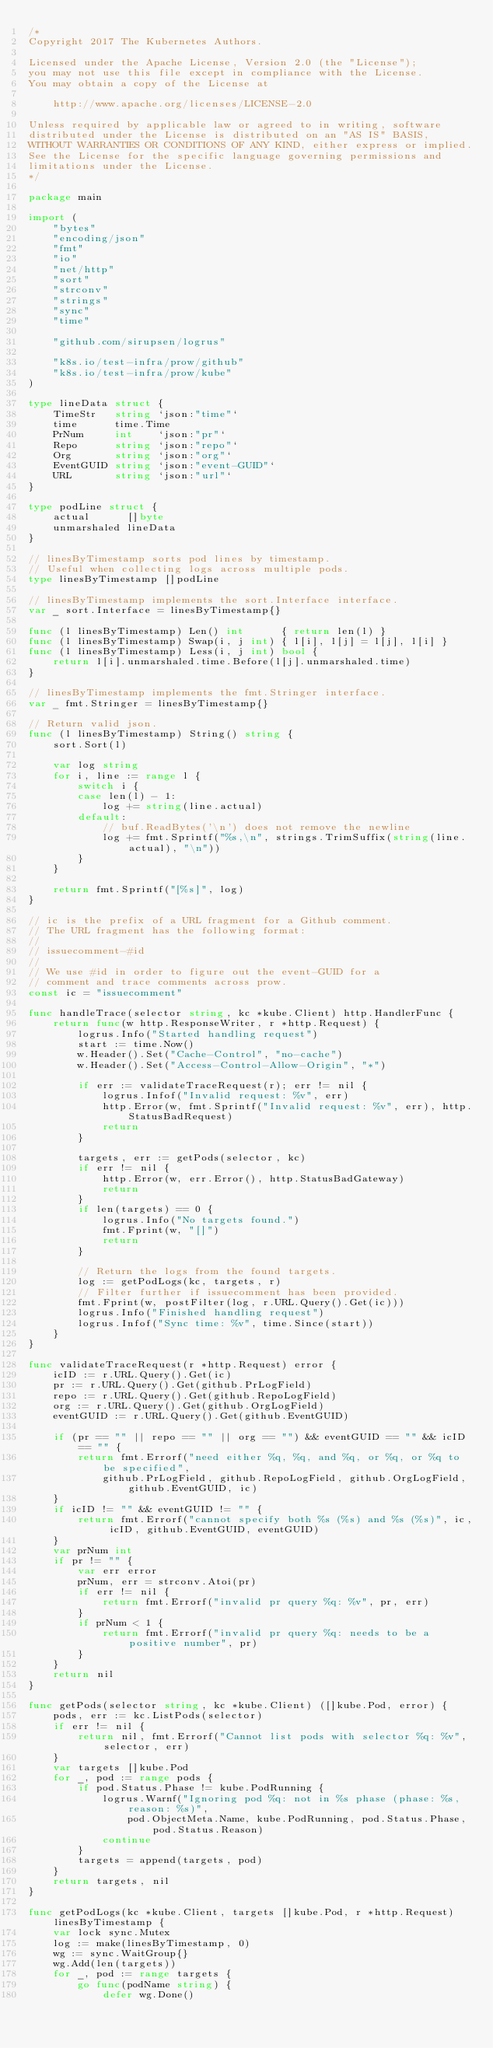<code> <loc_0><loc_0><loc_500><loc_500><_Go_>/*
Copyright 2017 The Kubernetes Authors.

Licensed under the Apache License, Version 2.0 (the "License");
you may not use this file except in compliance with the License.
You may obtain a copy of the License at

    http://www.apache.org/licenses/LICENSE-2.0

Unless required by applicable law or agreed to in writing, software
distributed under the License is distributed on an "AS IS" BASIS,
WITHOUT WARRANTIES OR CONDITIONS OF ANY KIND, either express or implied.
See the License for the specific language governing permissions and
limitations under the License.
*/

package main

import (
	"bytes"
	"encoding/json"
	"fmt"
	"io"
	"net/http"
	"sort"
	"strconv"
	"strings"
	"sync"
	"time"

	"github.com/sirupsen/logrus"

	"k8s.io/test-infra/prow/github"
	"k8s.io/test-infra/prow/kube"
)

type lineData struct {
	TimeStr   string `json:"time"`
	time      time.Time
	PrNum     int    `json:"pr"`
	Repo      string `json:"repo"`
	Org       string `json:"org"`
	EventGUID string `json:"event-GUID"`
	URL       string `json:"url"`
}

type podLine struct {
	actual      []byte
	unmarshaled lineData
}

// linesByTimestamp sorts pod lines by timestamp.
// Useful when collecting logs across multiple pods.
type linesByTimestamp []podLine

// linesByTimestamp implements the sort.Interface interface.
var _ sort.Interface = linesByTimestamp{}

func (l linesByTimestamp) Len() int      { return len(l) }
func (l linesByTimestamp) Swap(i, j int) { l[i], l[j] = l[j], l[i] }
func (l linesByTimestamp) Less(i, j int) bool {
	return l[i].unmarshaled.time.Before(l[j].unmarshaled.time)
}

// linesByTimestamp implements the fmt.Stringer interface.
var _ fmt.Stringer = linesByTimestamp{}

// Return valid json.
func (l linesByTimestamp) String() string {
	sort.Sort(l)

	var log string
	for i, line := range l {
		switch i {
		case len(l) - 1:
			log += string(line.actual)
		default:
			// buf.ReadBytes('\n') does not remove the newline
			log += fmt.Sprintf("%s,\n", strings.TrimSuffix(string(line.actual), "\n"))
		}
	}

	return fmt.Sprintf("[%s]", log)
}

// ic is the prefix of a URL fragment for a Github comment.
// The URL fragment has the following format:
//
// issuecomment-#id
//
// We use #id in order to figure out the event-GUID for a
// comment and trace comments across prow.
const ic = "issuecomment"

func handleTrace(selector string, kc *kube.Client) http.HandlerFunc {
	return func(w http.ResponseWriter, r *http.Request) {
		logrus.Info("Started handling request")
		start := time.Now()
		w.Header().Set("Cache-Control", "no-cache")
		w.Header().Set("Access-Control-Allow-Origin", "*")

		if err := validateTraceRequest(r); err != nil {
			logrus.Infof("Invalid request: %v", err)
			http.Error(w, fmt.Sprintf("Invalid request: %v", err), http.StatusBadRequest)
			return
		}

		targets, err := getPods(selector, kc)
		if err != nil {
			http.Error(w, err.Error(), http.StatusBadGateway)
			return
		}
		if len(targets) == 0 {
			logrus.Info("No targets found.")
			fmt.Fprint(w, "[]")
			return
		}

		// Return the logs from the found targets.
		log := getPodLogs(kc, targets, r)
		// Filter further if issuecomment has been provided.
		fmt.Fprint(w, postFilter(log, r.URL.Query().Get(ic)))
		logrus.Info("Finished handling request")
		logrus.Infof("Sync time: %v", time.Since(start))
	}
}

func validateTraceRequest(r *http.Request) error {
	icID := r.URL.Query().Get(ic)
	pr := r.URL.Query().Get(github.PrLogField)
	repo := r.URL.Query().Get(github.RepoLogField)
	org := r.URL.Query().Get(github.OrgLogField)
	eventGUID := r.URL.Query().Get(github.EventGUID)

	if (pr == "" || repo == "" || org == "") && eventGUID == "" && icID == "" {
		return fmt.Errorf("need either %q, %q, and %q, or %q, or %q to be specified",
			github.PrLogField, github.RepoLogField, github.OrgLogField, github.EventGUID, ic)
	}
	if icID != "" && eventGUID != "" {
		return fmt.Errorf("cannot specify both %s (%s) and %s (%s)", ic, icID, github.EventGUID, eventGUID)
	}
	var prNum int
	if pr != "" {
		var err error
		prNum, err = strconv.Atoi(pr)
		if err != nil {
			return fmt.Errorf("invalid pr query %q: %v", pr, err)
		}
		if prNum < 1 {
			return fmt.Errorf("invalid pr query %q: needs to be a positive number", pr)
		}
	}
	return nil
}

func getPods(selector string, kc *kube.Client) ([]kube.Pod, error) {
	pods, err := kc.ListPods(selector)
	if err != nil {
		return nil, fmt.Errorf("Cannot list pods with selector %q: %v", selector, err)
	}
	var targets []kube.Pod
	for _, pod := range pods {
		if pod.Status.Phase != kube.PodRunning {
			logrus.Warnf("Ignoring pod %q: not in %s phase (phase: %s, reason: %s)",
				pod.ObjectMeta.Name, kube.PodRunning, pod.Status.Phase, pod.Status.Reason)
			continue
		}
		targets = append(targets, pod)
	}
	return targets, nil
}

func getPodLogs(kc *kube.Client, targets []kube.Pod, r *http.Request) linesByTimestamp {
	var lock sync.Mutex
	log := make(linesByTimestamp, 0)
	wg := sync.WaitGroup{}
	wg.Add(len(targets))
	for _, pod := range targets {
		go func(podName string) {
			defer wg.Done()</code> 